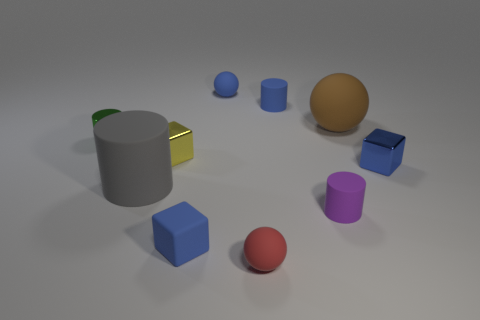The gray cylinder that is made of the same material as the tiny purple cylinder is what size?
Provide a succinct answer. Large. There is a blue cube behind the rubber block; is its size the same as the rubber cylinder that is to the left of the tiny red ball?
Make the answer very short. No. Is the size of the yellow object the same as the ball that is right of the red matte thing?
Ensure brevity in your answer.  No. The tiny cube that is behind the block on the right side of the big matte ball is made of what material?
Offer a very short reply. Metal. How many matte objects are to the right of the tiny yellow metal object and on the left side of the small blue cylinder?
Keep it short and to the point. 3. What number of other objects are the same size as the red thing?
Your response must be concise. 7. There is a big thing behind the small metallic cylinder; is its shape the same as the blue matte object behind the small blue cylinder?
Your answer should be very brief. Yes. There is a green thing; are there any purple rubber cylinders right of it?
Offer a terse response. Yes. There is a large object that is the same shape as the tiny green object; what is its color?
Provide a succinct answer. Gray. There is a block that is in front of the big gray cylinder; what is it made of?
Make the answer very short. Rubber. 